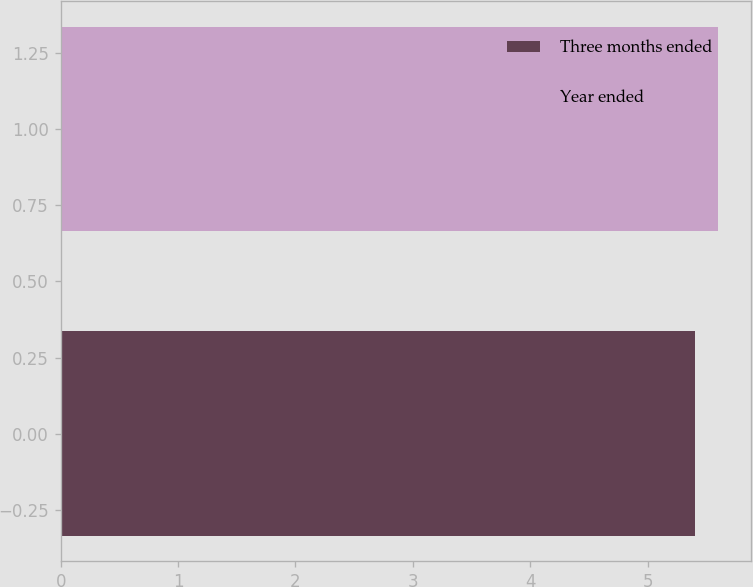Convert chart to OTSL. <chart><loc_0><loc_0><loc_500><loc_500><bar_chart><fcel>Three months ended<fcel>Year ended<nl><fcel>5.4<fcel>5.6<nl></chart> 